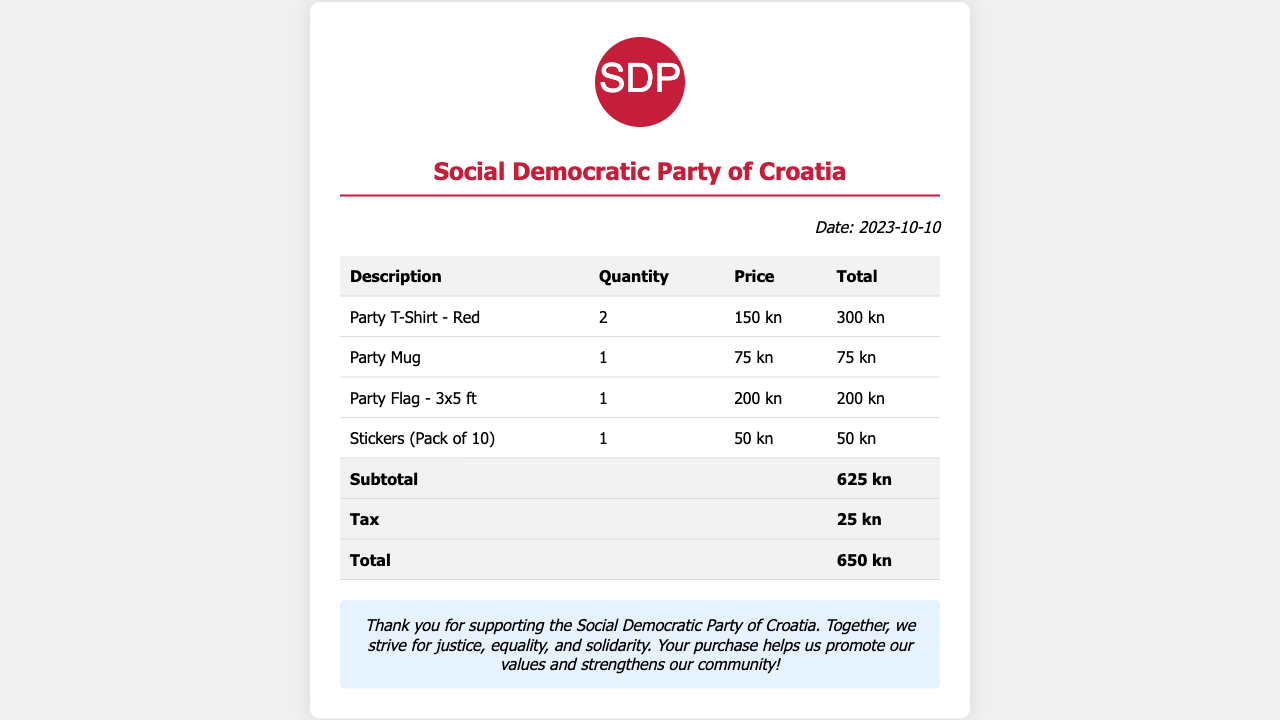What is the date of the receipt? The date is specified in the document as "Date: 2023-10-10".
Answer: 2023-10-10 What is the price of the Party Mug? The document shows "Party Mug" priced at "75 kn".
Answer: 75 kn What is the total amount spent? The total amount is listed as "Total: 650 kn" in the receipt.
Answer: 650 kn How many Party T-Shirts were purchased? The quantity for "Party T-Shirt - Red" is indicated as "2".
Answer: 2 What message is included at the bottom of the receipt? The document contains a message thanking the buyer and promoting values of the party.
Answer: Thank you for supporting the Social Democratic Party of Croatia. Together, we strive for justice, equality, and solidarity What is the subtotal amount before tax? The subtotal amount is clearly stated as "Subtotal: 625 kn".
Answer: 625 kn How many items are listed in the receipt? There are four items listed in the table as merchandise purchased.
Answer: 4 What item has the highest price? The document indicates that "Party Flag - 3x5 ft" has the price of "200 kn".
Answer: Party Flag - 3x5 ft What is the tax amount charged? The tax amount is clearly shown as "Tax: 25 kn" in the receipt.
Answer: 25 kn 